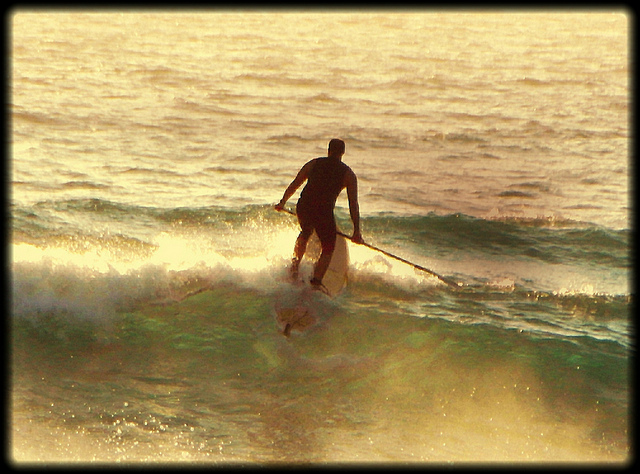What kind of safety precautions should the man take while engaging in this activity? The man should take several safety precautions, including wearing a life jacket and a leash to ensure he stays connected to his board. It's also wise to check weather and water conditions before heading out, carry a whistle or communication device for emergencies, and inform someone about his plan and expected return time. Staying hydrated and understanding the local marine life and potential hazards are also important for a safe paddleboarding experience. What are some benefits of paddleboarding compared to other water sports? Paddleboarding offers unique benefits compared to other water sports. It provides a full-body workout that engages the core, legs, and upper body, enhancing strength and endurance. It’s known for being a low-impact activity that’s easy on the joints, making it accessible for people of various age groups and fitness levels. Additionally, paddleboarding can be both relaxing and meditative, offering opportunities to explore tranquil waters at one's own pace. It also provides versatility, as it can be done on lakes, rivers, and oceans, and adapted for activities such as yoga or fishing. 